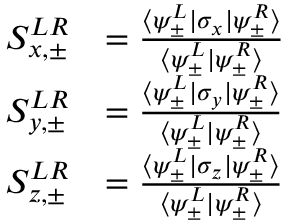Convert formula to latex. <formula><loc_0><loc_0><loc_500><loc_500>\begin{array} { r l } { S _ { x , \pm } ^ { L R } } & { = \frac { \langle \psi _ { \pm } ^ { L } | \sigma _ { x } | \psi _ { \pm } ^ { R } \rangle } { \langle \psi _ { \pm } ^ { L } | \psi _ { \pm } ^ { R } \rangle } } \\ { S _ { y , \pm } ^ { L R } } & { = \frac { \langle \psi _ { \pm } ^ { L } | \sigma _ { y } | \psi _ { \pm } ^ { R } \rangle } { \langle \psi _ { \pm } ^ { L } | \psi _ { \pm } ^ { R } \rangle } } \\ { S _ { z , \pm } ^ { L R } } & { = \frac { \langle \psi _ { \pm } ^ { L } | \sigma _ { z } | \psi _ { \pm } ^ { R } \rangle } { \langle \psi _ { \pm } ^ { L } | \psi _ { \pm } ^ { R } \rangle } } \end{array}</formula> 